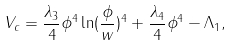<formula> <loc_0><loc_0><loc_500><loc_500>V _ { c } = \frac { \lambda _ { 3 } } { 4 } \phi ^ { 4 } \ln ( \frac { \phi } { w } ) ^ { 4 } + \frac { \lambda _ { 4 } } { 4 } \phi ^ { 4 } - \Lambda _ { 1 } ,</formula> 